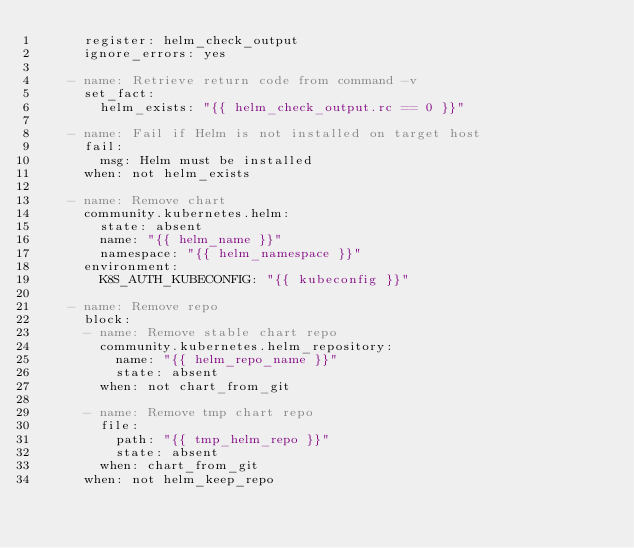Convert code to text. <code><loc_0><loc_0><loc_500><loc_500><_YAML_>      register: helm_check_output
      ignore_errors: yes

    - name: Retrieve return code from command -v
      set_fact:
        helm_exists: "{{ helm_check_output.rc == 0 }}"

    - name: Fail if Helm is not installed on target host
      fail:
        msg: Helm must be installed
      when: not helm_exists

    - name: Remove chart
      community.kubernetes.helm:
        state: absent
        name: "{{ helm_name }}"
        namespace: "{{ helm_namespace }}"
      environment:
        K8S_AUTH_KUBECONFIG: "{{ kubeconfig }}"

    - name: Remove repo
      block:
      - name: Remove stable chart repo
        community.kubernetes.helm_repository:
          name: "{{ helm_repo_name }}"
          state: absent
        when: not chart_from_git

      - name: Remove tmp chart repo
        file:
          path: "{{ tmp_helm_repo }}"
          state: absent
        when: chart_from_git
      when: not helm_keep_repo</code> 